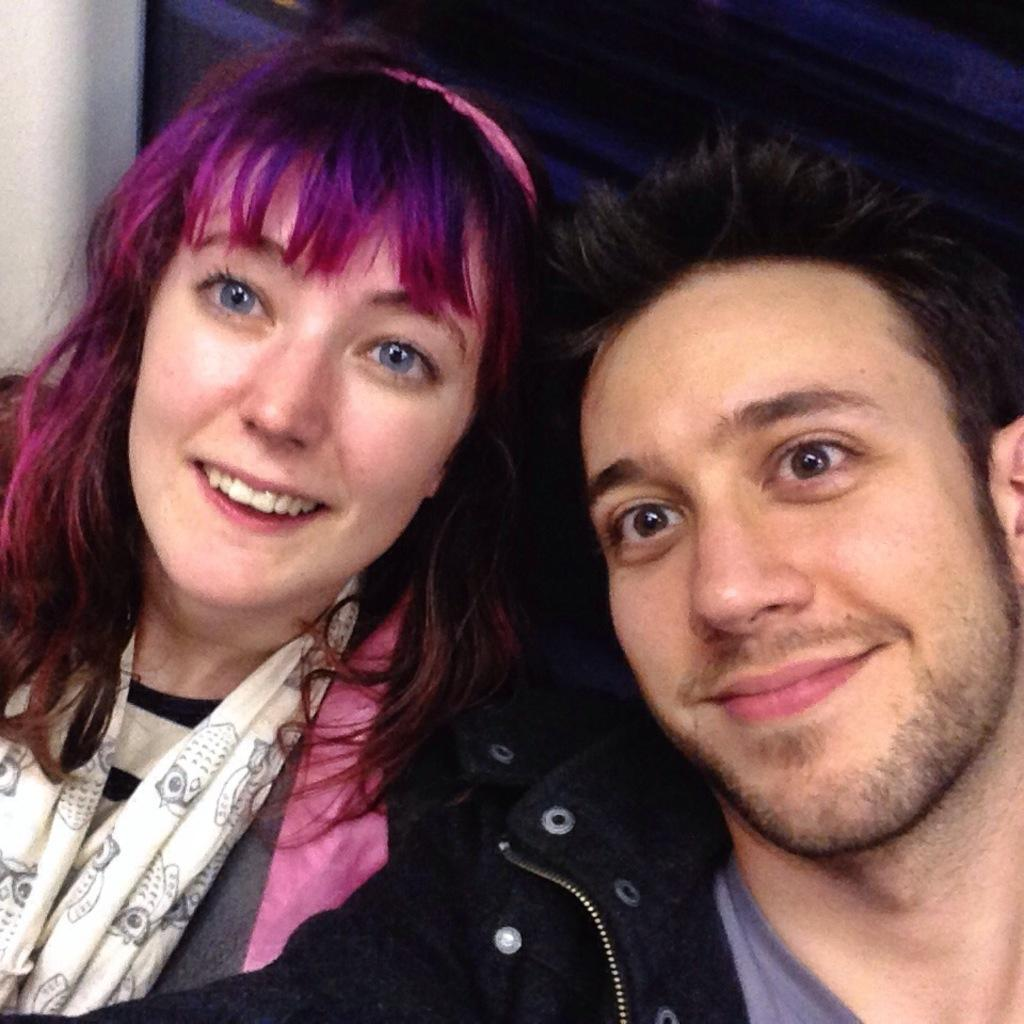How many people are in the image? There are two people in the image. What expression do the people have in the image? The people are smiling in the image. What can be observed about the background of the image? The background of the image is dark. What is the weather like in the image? The provided facts do not mention any information about the weather, so it cannot be determined from the image. 